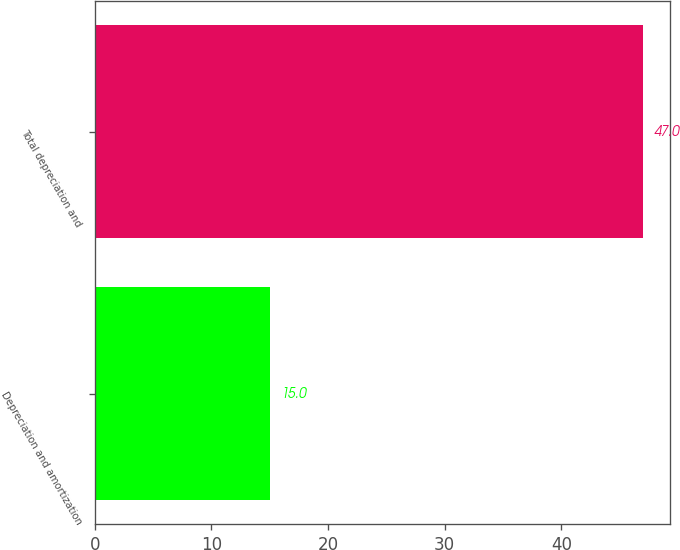Convert chart to OTSL. <chart><loc_0><loc_0><loc_500><loc_500><bar_chart><fcel>Depreciation and amortization<fcel>Total depreciation and<nl><fcel>15<fcel>47<nl></chart> 